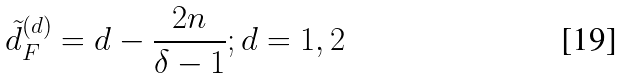Convert formula to latex. <formula><loc_0><loc_0><loc_500><loc_500>\tilde { d } ^ { ( d ) } _ { F } = d - \frac { 2 n } { \delta - 1 } ; d = 1 , 2</formula> 